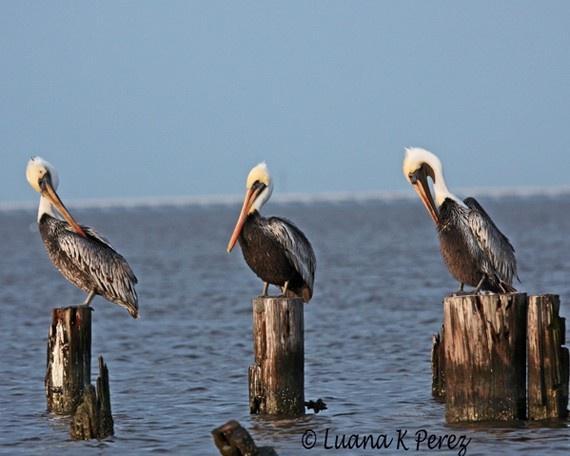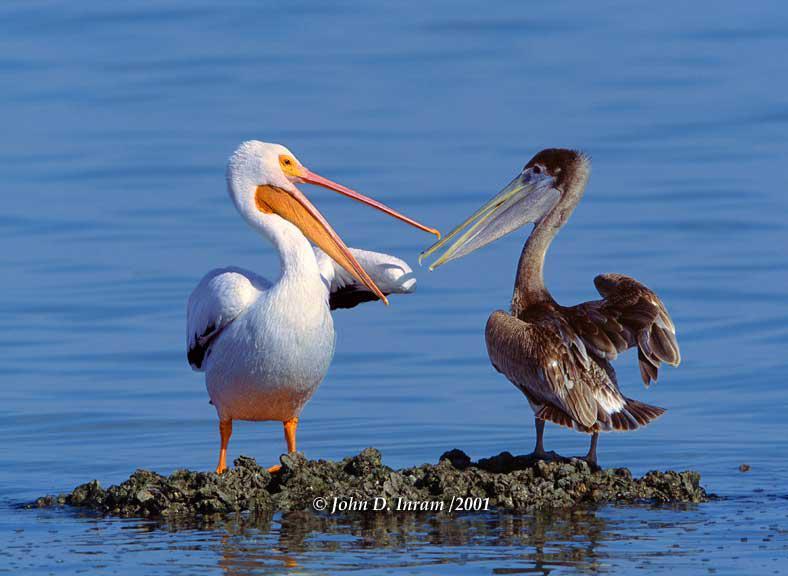The first image is the image on the left, the second image is the image on the right. Examine the images to the left and right. Is the description "Three pelicans perch on wood posts in the water in the left image." accurate? Answer yes or no. Yes. The first image is the image on the left, the second image is the image on the right. For the images displayed, is the sentence "Three birds are standing on posts in water in the image on the left." factually correct? Answer yes or no. Yes. 